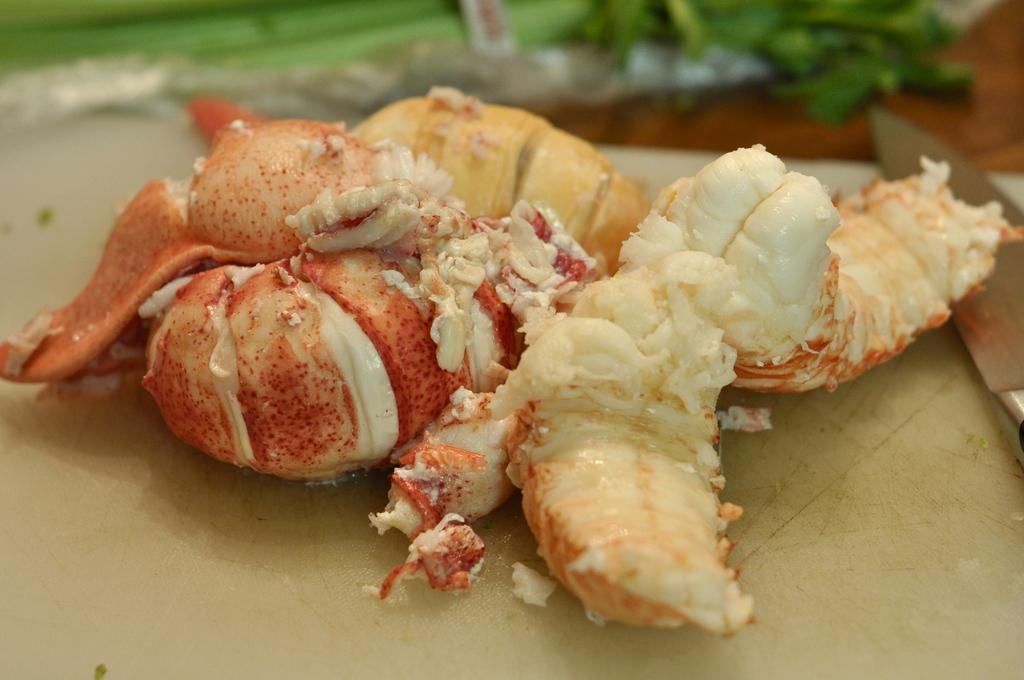What is present in the image related to food? There is food in the image. What utensil can be seen in the image? There is a knife in the image. Where are the food and knife located? The food and knife are on a platform. How would you describe the background of the image? The background of the image is blurry. How many babies are crawling on the platform with the food and knife in the image? There are no babies present in the image; it only features food and a knife on a platform with a blurry background. 